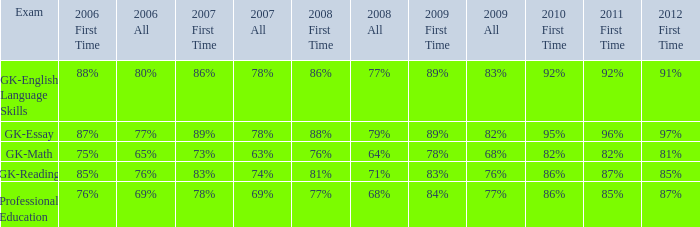What is the percentage for 2008 First time when in 2006 it was 85%? 81%. 